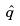Convert formula to latex. <formula><loc_0><loc_0><loc_500><loc_500>\hat { q }</formula> 